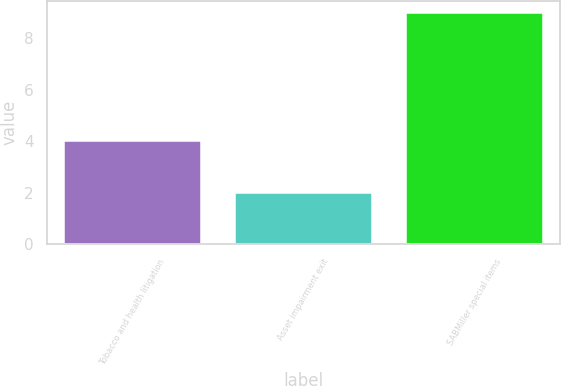Convert chart. <chart><loc_0><loc_0><loc_500><loc_500><bar_chart><fcel>Tobacco and health litigation<fcel>Asset impairment exit<fcel>SABMiller special items<nl><fcel>4<fcel>2<fcel>9<nl></chart> 